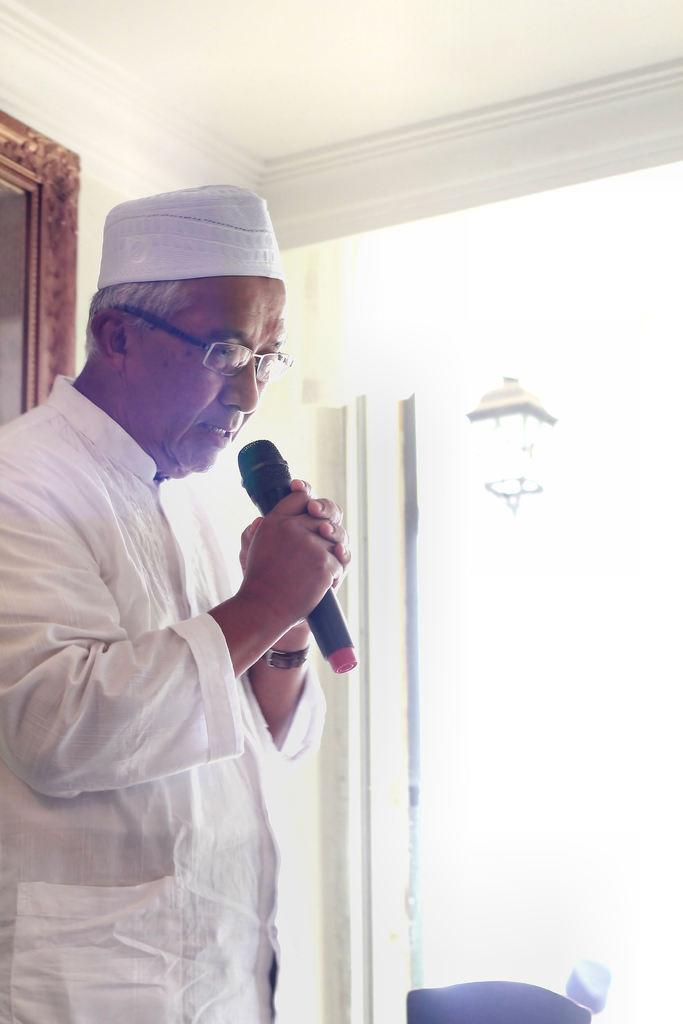Who is the main subject in the foreground of the image? There is a man in the foreground of the image. What is the man holding in the image? The man is holding a mic. How is the image presented? The image appears to be framed. What can be seen in the background of the image? There is a window and a lamp in the background of the image. Can you tell me how many quince are on the table in the image? There are no quince present in the image. What type of cat can be seen sleeping on the man's lap in the image? There is no cat present in the image. 